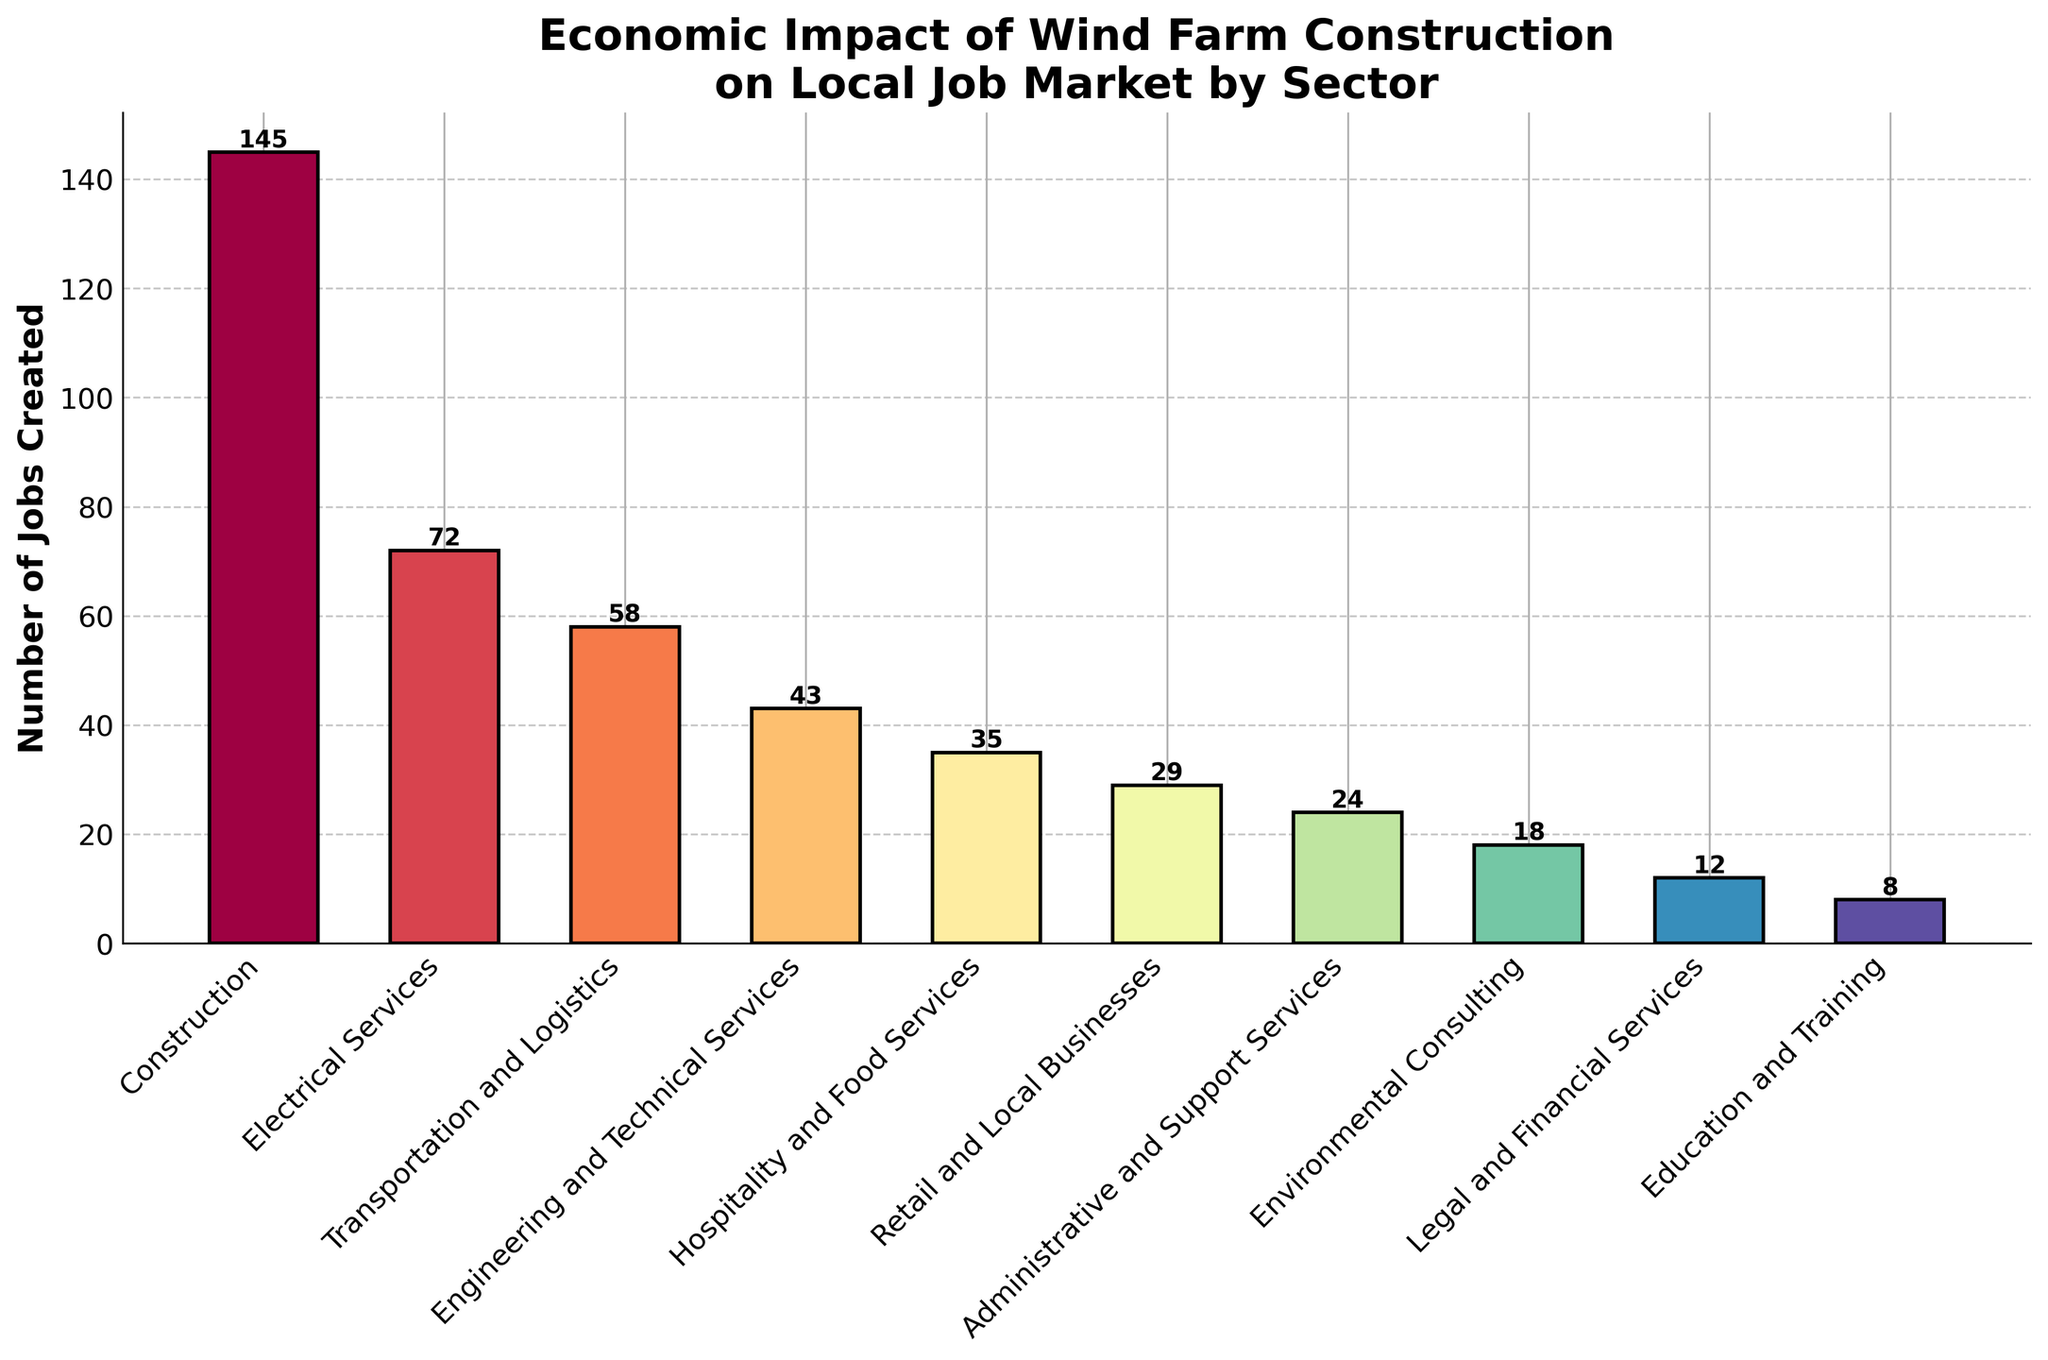Which sector created the highest number of jobs? By looking at the height of the bars, the tallest bar represents the Construction sector with 145 jobs created.
Answer: Construction How many more jobs did Electrical Services create compared to Legal and Financial Services? Electrical Services created 72 jobs, and Legal and Financial Services created 12 jobs. The difference is 72 - 12 = 60 jobs.
Answer: 60 What is the total number of jobs created by Retail and Local Businesses, Administrative and Support Services, and Environmental Consulting? Adding the jobs created: Retail and Local Businesses (29) + Administrative and Support Services (24) + Environmental Consulting (18) = 29 + 24 + 18 = 71 jobs.
Answer: 71 Compare the number of jobs created in Transportation and Logistics with those in Engineering and Technical Services. Which one is higher, and by how much? Transportation and Logistics created 58 jobs, while Engineering and Technical Services created 43 jobs. Transportation and Logistics is higher by 58 - 43 = 15 jobs.
Answer: Transportation and Logistics by 15 Which color bar is the tallest? The tallest bar, representing the Construction sector, is colored with the first shade in the Spectral color map, which would be at the red end of the spectrum.
Answer: Red What’s the average number of jobs created across all sectors? Summing all the jobs created: 145 + 72 + 58 + 43 + 35 + 29 + 24 + 18 + 12 + 8 = 444. The number of sectors is 10, so the average is 444 / 10 = 44.4 jobs.
Answer: 44.4 By how many jobs does the Construction sector exceed the sum of the jobs in Education and Training, and Legal and Financial Services? Construction created 145 jobs. Education and Training created 8 jobs and Legal and Financial Services created 12 jobs. The sum is 8 + 12 = 20. The difference is 145 - 20 = 125 jobs.
Answer: 125 What percentage of the total jobs created is in Electrical Services? Total jobs created is 444. Electrical Services created 72 jobs. The percentage is (72 / 444) * 100 ≈ 16.22%.
Answer: 16.22% Which sectors created fewer than 20 jobs? The bars that are shorter than the mark for 20 jobs are Environmental Consulting (18 jobs), Legal and Financial Services (12 jobs), and Education and Training (8 jobs).
Answer: Environmental Consulting, Legal and Financial Services, Education and Training Identify a sector that is represented by a greenish bar and state the number of jobs it created. By looking at the colors, a greenish bar towards the middle of the Spectral color map likely represents Engineering and Technical Services, which created 43 jobs.
Answer: Engineering and Technical Services, 43 jobs 